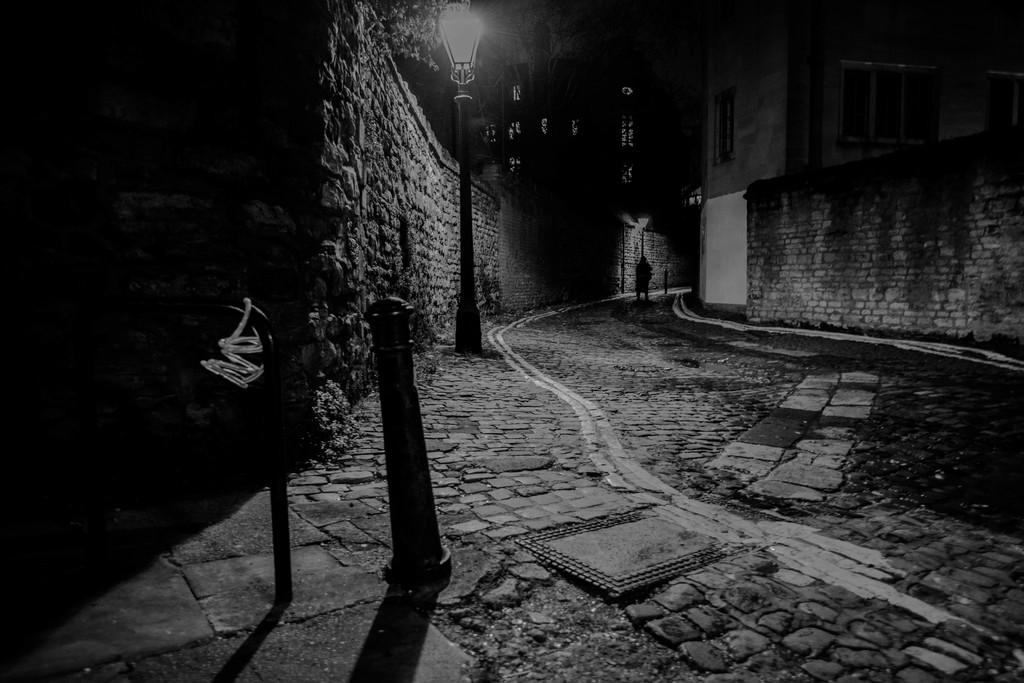What structure is located in the left corner of the image? There is a wall in the left corner of the image. What object is also present in the left corner of the image? There is a street light in the left corner of the image. What type of building can be seen in the right corner of the image? There is a building in the right corner of the image. Can you describe the person in the image? There is a person standing in the background of the image. What type of gun is the rat holding in the image? There is no rat or gun present in the image. How does the person in the image plan to smash the building? There is no indication in the image that the person is planning to smash the building. 